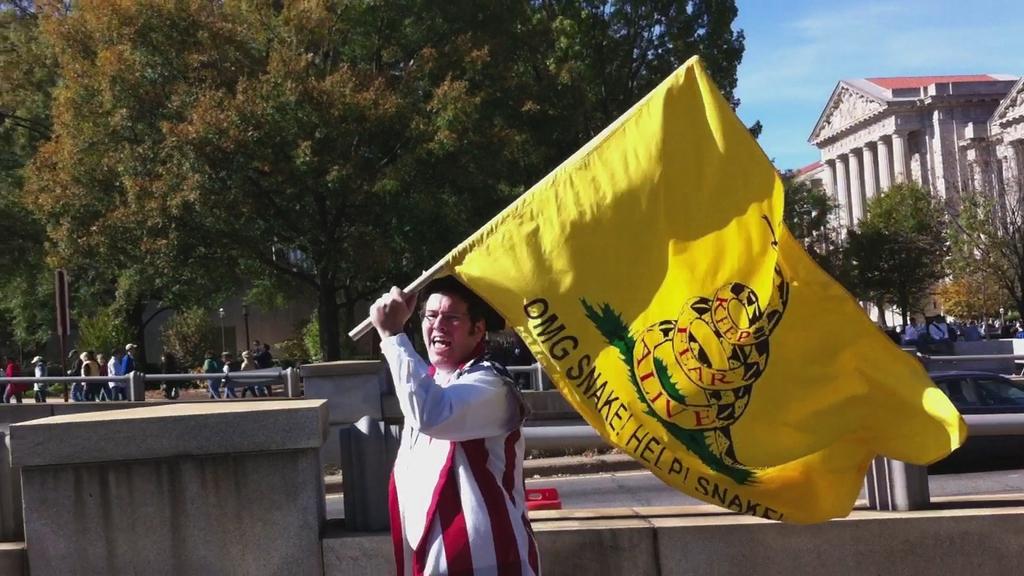Whats on the flier?
Give a very brief answer. Omg snake! help! snake!. 